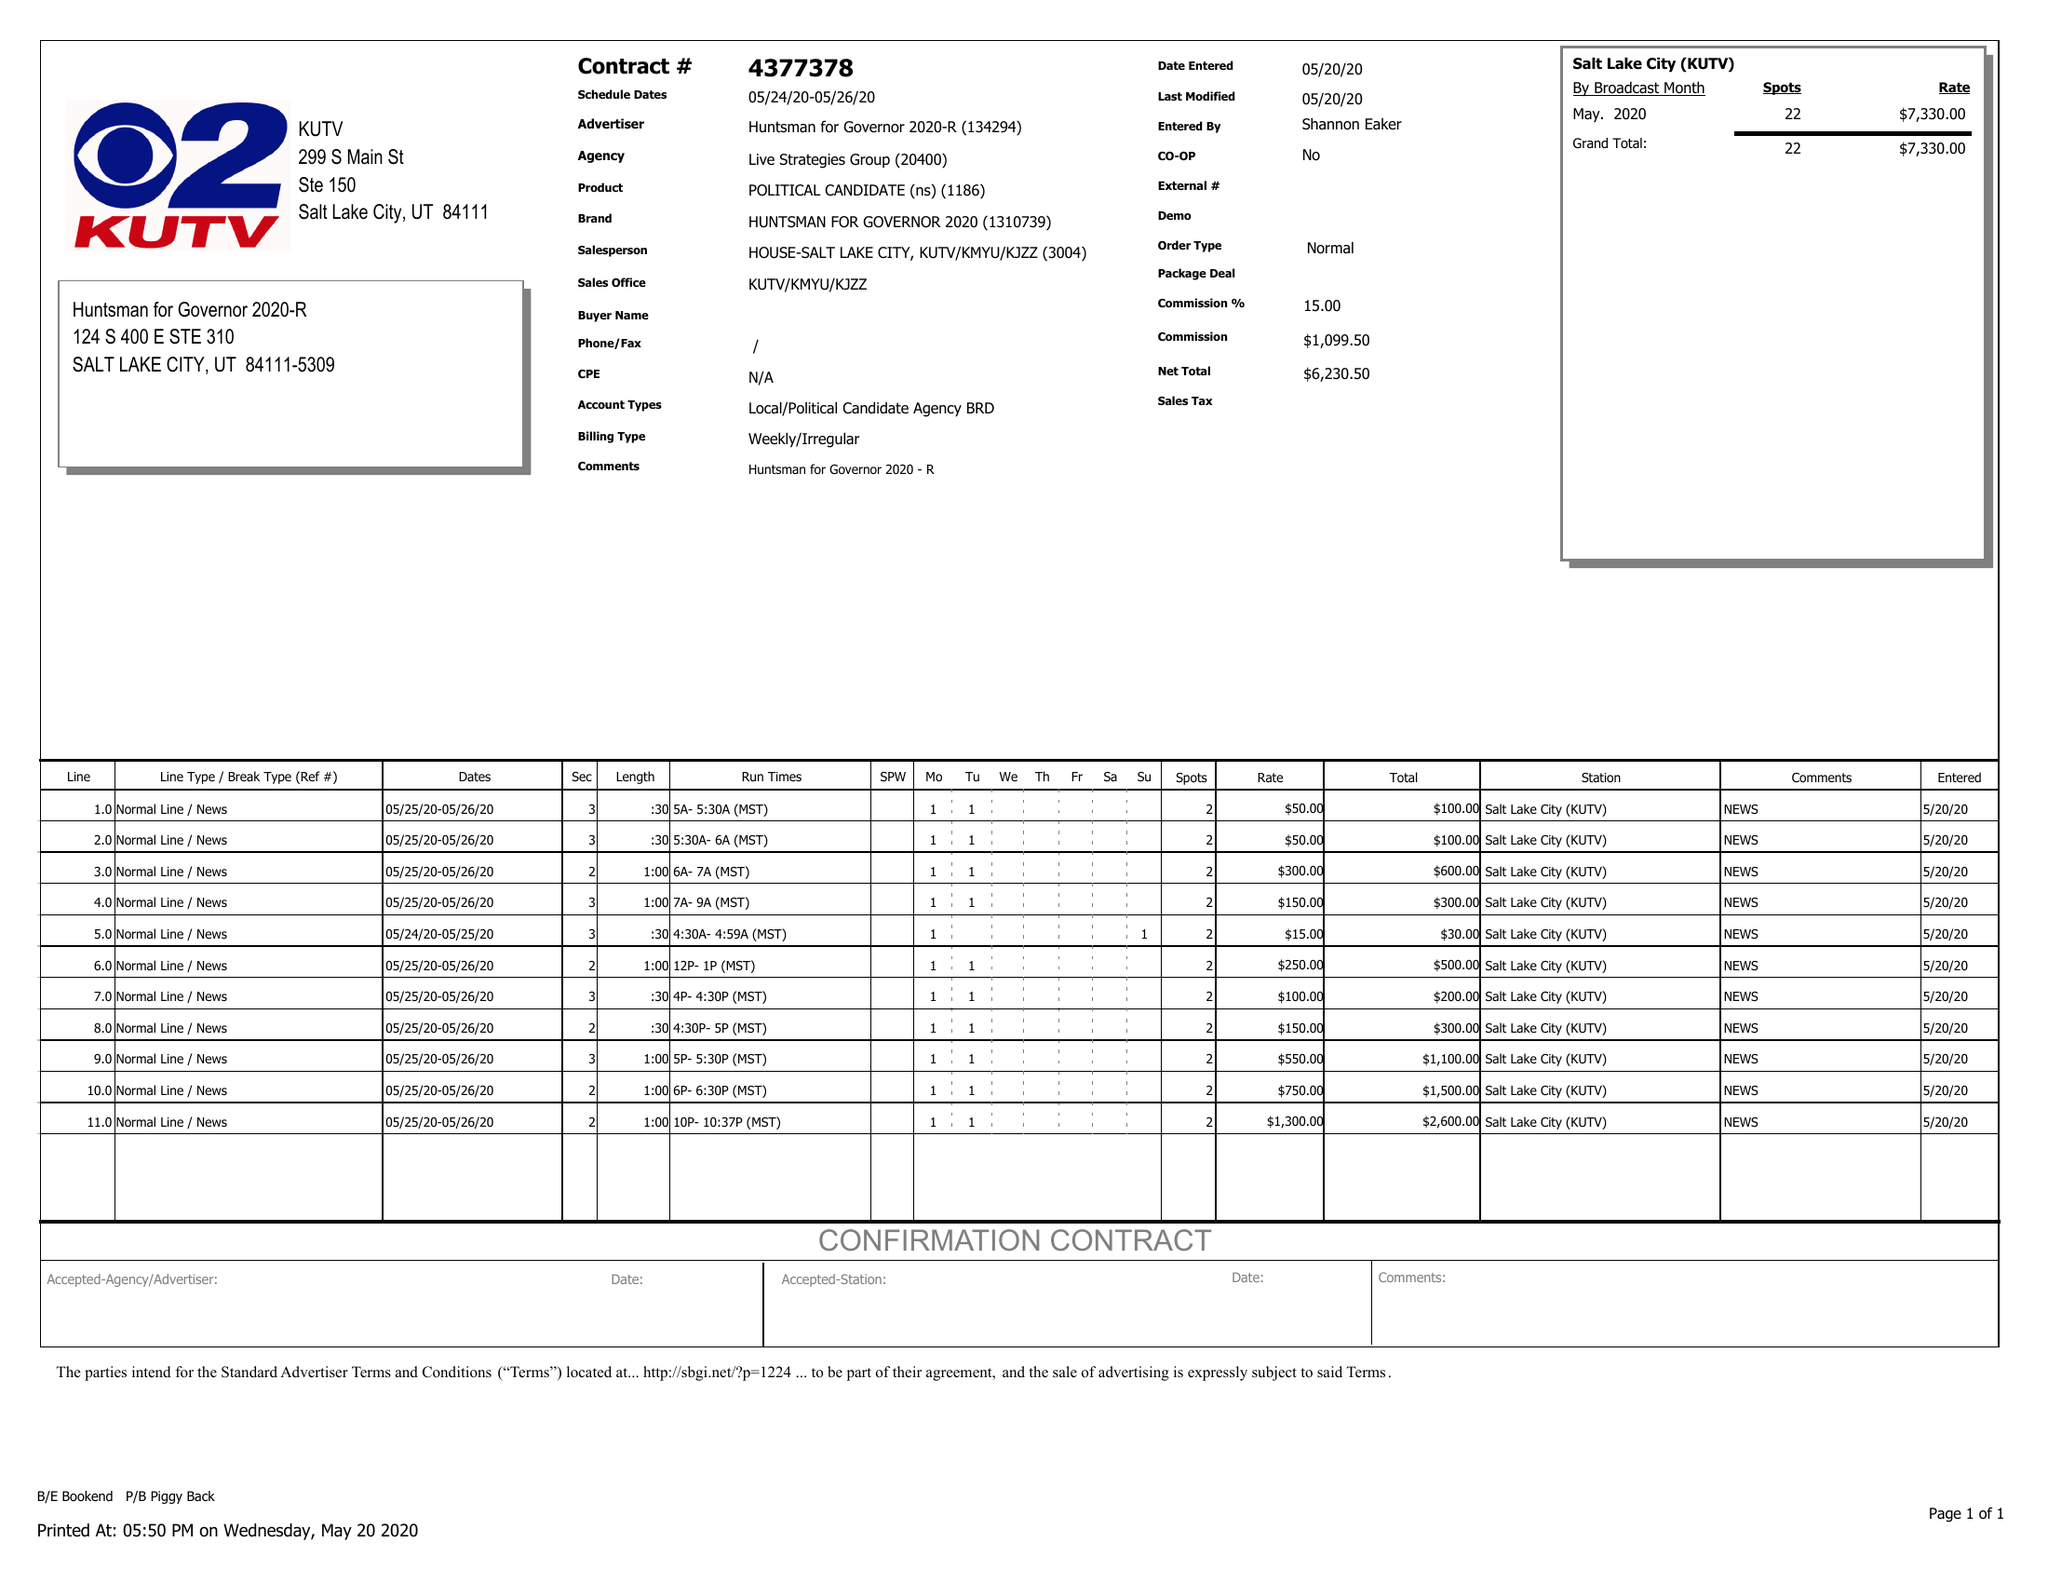What is the value for the flight_from?
Answer the question using a single word or phrase. 05/24/20 